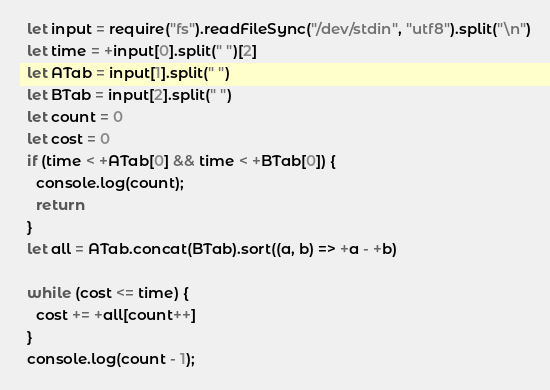Convert code to text. <code><loc_0><loc_0><loc_500><loc_500><_JavaScript_>  let input = require("fs").readFileSync("/dev/stdin", "utf8").split("\n")
  let time = +input[0].split(" ")[2]
  let ATab = input[1].split(" ")
  let BTab = input[2].split(" ")
  let count = 0
  let cost = 0
  if (time < +ATab[0] && time < +BTab[0]) {
    console.log(count);
    return
  }
  let all = ATab.concat(BTab).sort((a, b) => +a - +b)

  while (cost <= time) {
    cost += +all[count++]
  }
  console.log(count - 1);</code> 